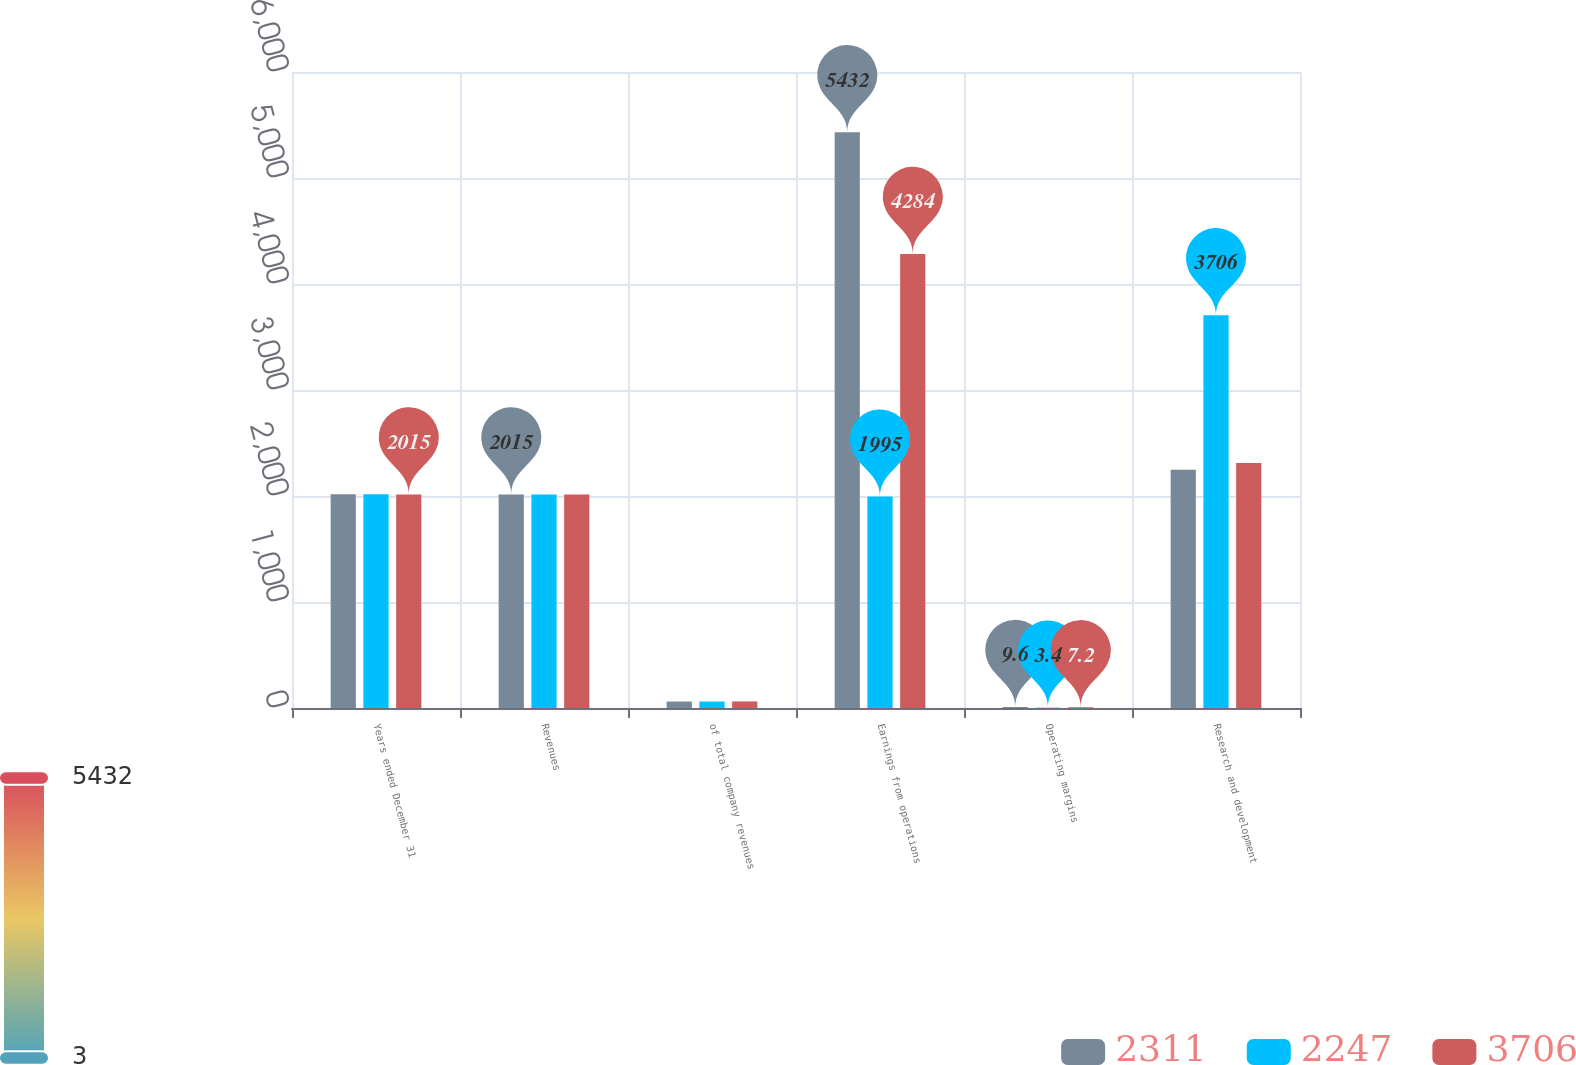Convert chart. <chart><loc_0><loc_0><loc_500><loc_500><stacked_bar_chart><ecel><fcel>Years ended December 31<fcel>Revenues<fcel>of total company revenues<fcel>Earnings from operations<fcel>Operating margins<fcel>Research and development<nl><fcel>2311<fcel>2017<fcel>2015<fcel>61<fcel>5432<fcel>9.6<fcel>2247<nl><fcel>2247<fcel>2016<fcel>2015<fcel>61<fcel>1995<fcel>3.4<fcel>3706<nl><fcel>3706<fcel>2015<fcel>2015<fcel>62<fcel>4284<fcel>7.2<fcel>2311<nl></chart> 